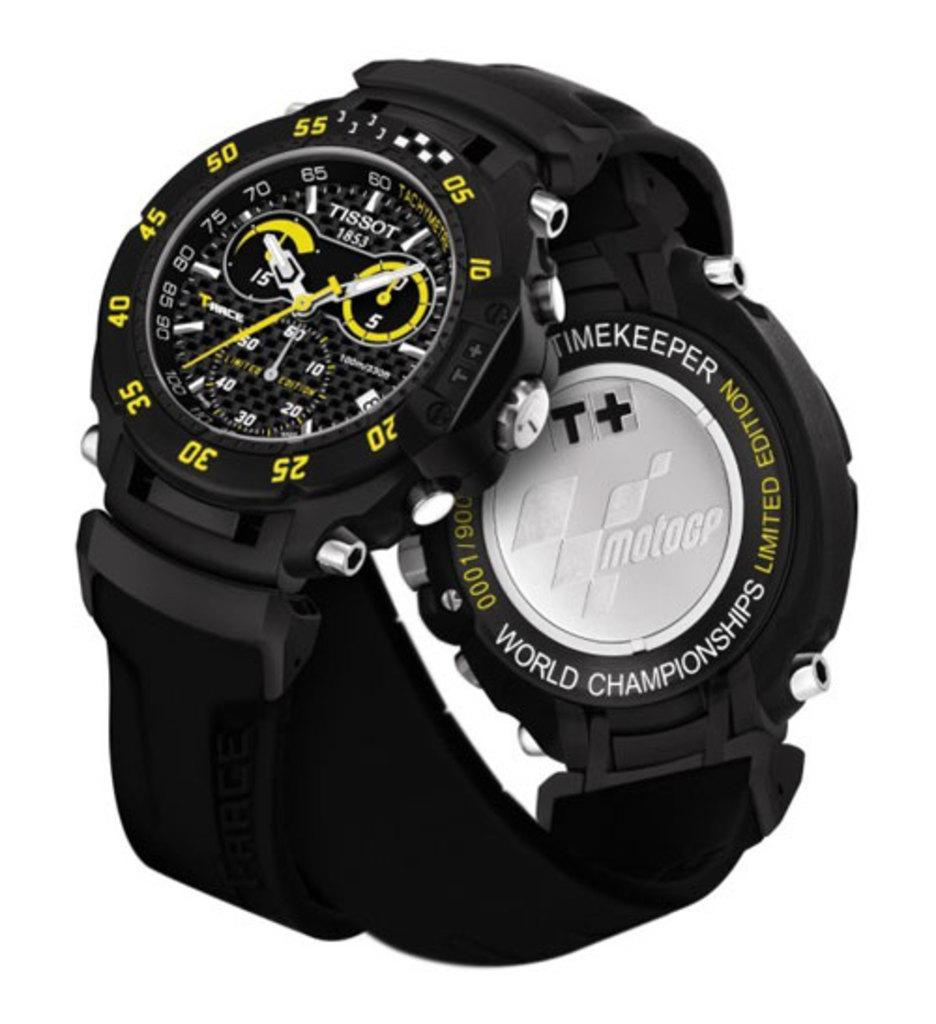<image>
Relay a brief, clear account of the picture shown. A limited edition world championship watch sits with another watch from Tissot. 